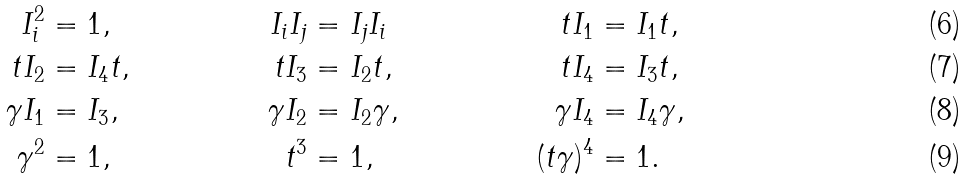Convert formula to latex. <formula><loc_0><loc_0><loc_500><loc_500>I _ { i } ^ { 2 } & = 1 , & I _ { i } I _ { j } & = I _ { j } I _ { i } & t I _ { 1 } & = I _ { 1 } t , & \\ t I _ { 2 } & = I _ { 4 } t , & t I _ { 3 } & = I _ { 2 } t , & t I _ { 4 } & = I _ { 3 } t , & \\ \gamma I _ { 1 } & = I _ { 3 } , & \gamma I _ { 2 } & = I _ { 2 } \gamma , & \gamma I _ { 4 } & = I _ { 4 } \gamma , & \\ \gamma ^ { 2 } & = 1 , & t ^ { 3 } & = 1 , & ( t \gamma ) ^ { 4 } & = 1 . &</formula> 